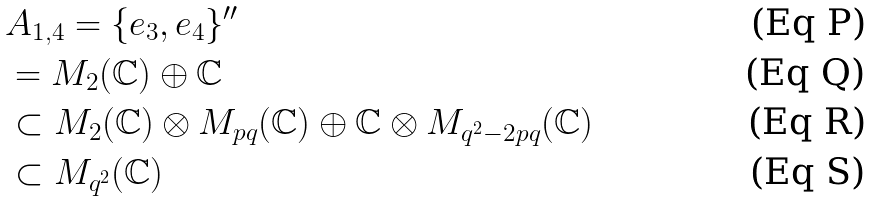Convert formula to latex. <formula><loc_0><loc_0><loc_500><loc_500>& A _ { 1 , 4 } = \{ e _ { 3 } , e _ { 4 } \} ^ { \prime \prime } \\ & = M _ { 2 } ( { \mathbb { C } } ) \oplus { \mathbb { C } } \\ & \subset M _ { 2 } ( { \mathbb { C } } ) \otimes M _ { p q } ( { \mathbb { C } } ) \oplus { \mathbb { C } } \otimes M _ { q ^ { 2 } - 2 p q } ( { \mathbb { C } } ) \\ & \subset M _ { q ^ { 2 } } ( { \mathbb { C } } )</formula> 